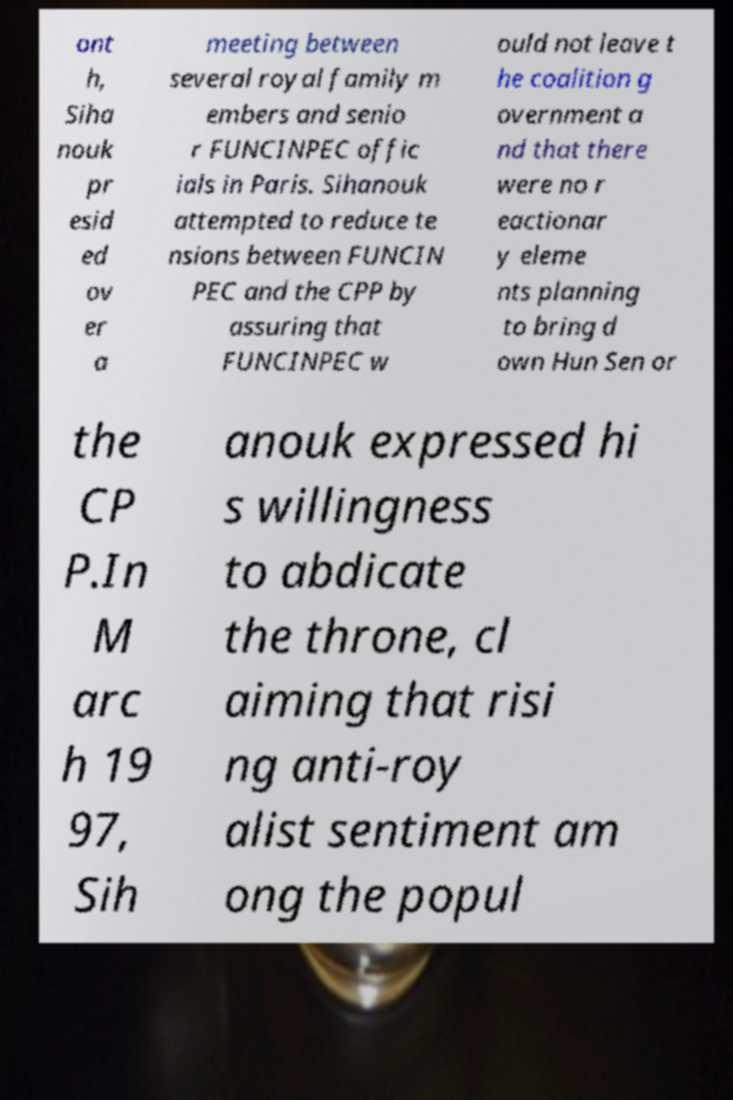Please identify and transcribe the text found in this image. ont h, Siha nouk pr esid ed ov er a meeting between several royal family m embers and senio r FUNCINPEC offic ials in Paris. Sihanouk attempted to reduce te nsions between FUNCIN PEC and the CPP by assuring that FUNCINPEC w ould not leave t he coalition g overnment a nd that there were no r eactionar y eleme nts planning to bring d own Hun Sen or the CP P.In M arc h 19 97, Sih anouk expressed hi s willingness to abdicate the throne, cl aiming that risi ng anti-roy alist sentiment am ong the popul 